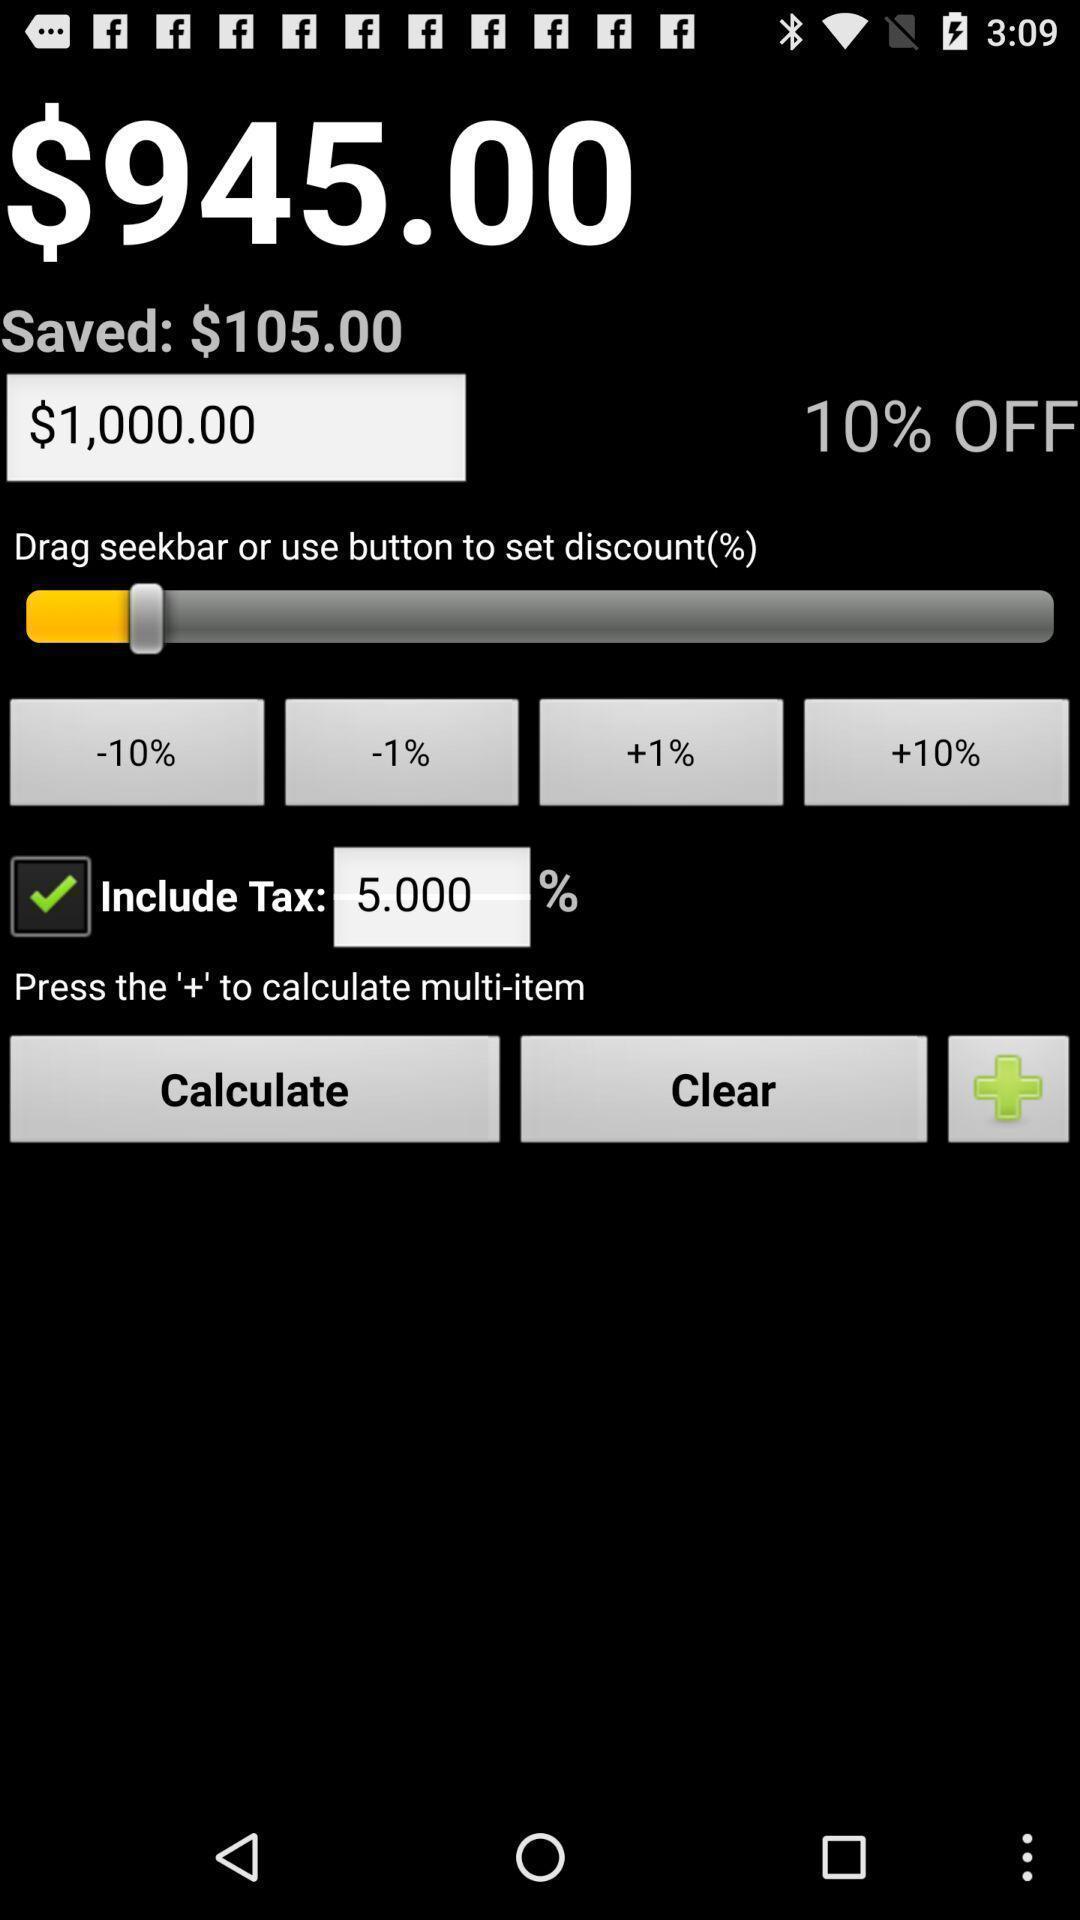Explain the elements present in this screenshot. Screen page of a discount calculator. 